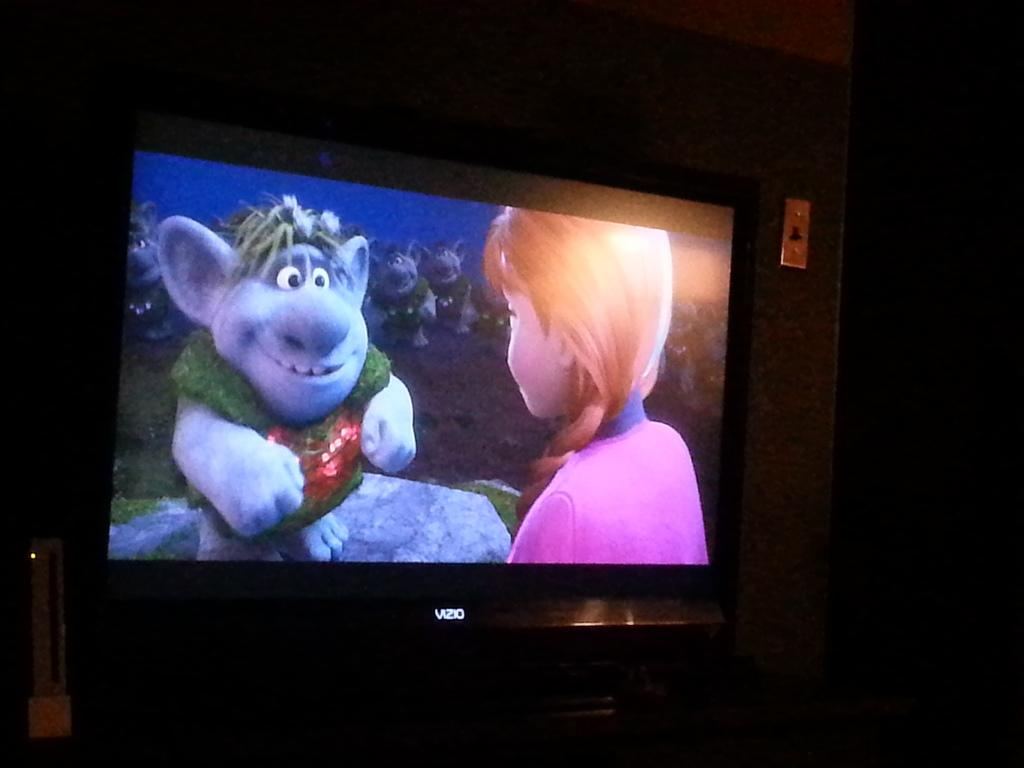<image>
Provide a brief description of the given image. A movie playing on a Vzio brand screen. 